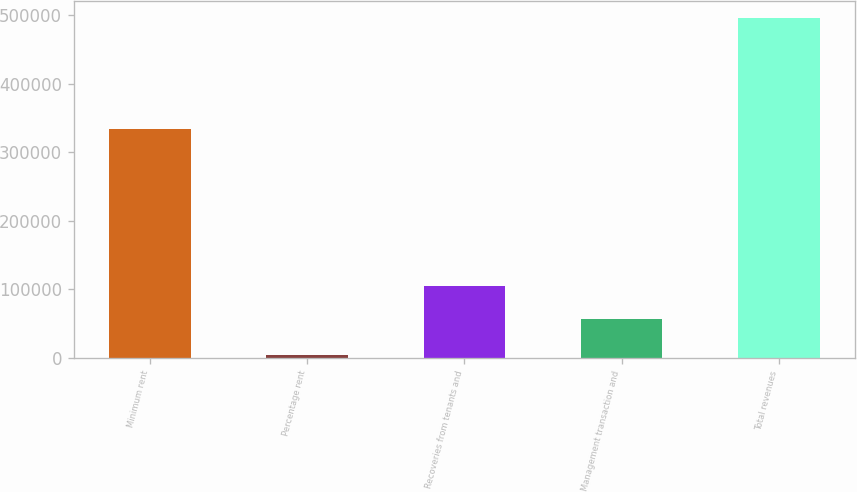Convert chart to OTSL. <chart><loc_0><loc_0><loc_500><loc_500><bar_chart><fcel>Minimum rent<fcel>Percentage rent<fcel>Recoveries from tenants and<fcel>Management transaction and<fcel>Total revenues<nl><fcel>334509<fcel>4258<fcel>105196<fcel>56032<fcel>495895<nl></chart> 